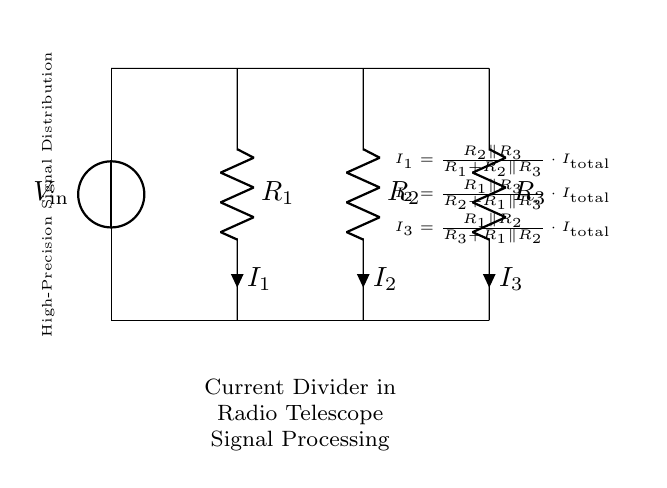What is the input voltage in this circuit? The circuit diagram specifies the voltage source as \( V_\text{in} \), which signifies the input voltage to the current divider.
Answer: V in What are the resistances connected in the circuit? The circuit shows three resistors labeled as \( R_1 \), \( R_2 \), and \( R_3 \). These components are crucial for determining how the total current splits among the branches.
Answer: R1, R2, R3 How many branches are formed in the current divider circuit? The circuit displays three resistors, which create three branches for the current to flow through, with each branch containing one of the resistors.
Answer: Three What is the total current entering the circuit? The circuit does not provide a specific value for \( I_\text{total} \), but it is denoted as the total current feeding the parallel combination of the resistors.
Answer: I total What will happen to the current in \( R_1 \) if \( R_2 \) is decreased? Reducing \( R_2 \) will increase the current through \( R_1 \) since the total resistance of the parallel combination decreases, resulting in a higher total current being divided, thus increasing \( I_1 \).
Answer: Increase What is the formula for \( I_2 \) in the circuit? The diagram includes text that provides the formula for \( I_2 \), which is \( I_2 = \frac{R_1 \parallel R_3}{R_2 + R_1 \parallel R_3} \cdot I_\text{total} \). This equation describes how the input current is distributed based on the resistances.
Answer: I2 equals R1 parallel R3 over R2 plus R1 parallel R3 times I total Which component is responsible for the current division? The resistors \( R_1 \), \( R_2 \), and \( R_3 \) each play a role in determining how the total current splits, but the arrangement in parallel is the key factor in the current division process.
Answer: Resistors 